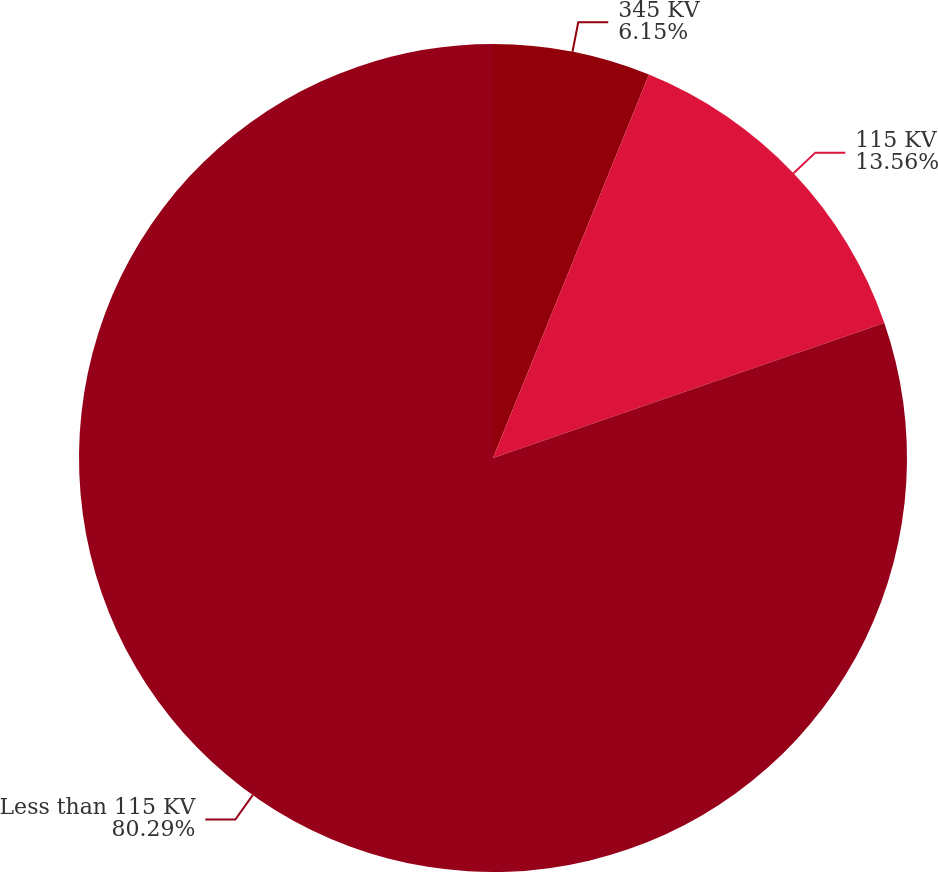Convert chart to OTSL. <chart><loc_0><loc_0><loc_500><loc_500><pie_chart><fcel>345 KV<fcel>115 KV<fcel>Less than 115 KV<nl><fcel>6.15%<fcel>13.56%<fcel>80.29%<nl></chart> 